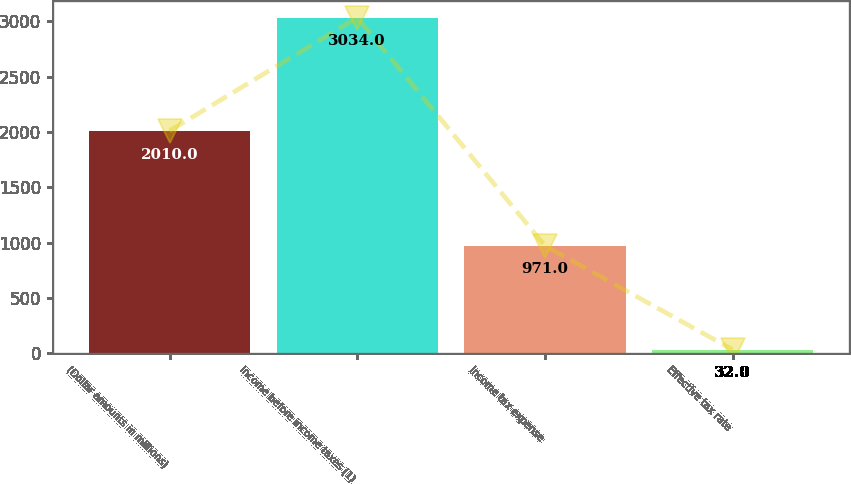<chart> <loc_0><loc_0><loc_500><loc_500><bar_chart><fcel>(Dollar amounts in millions)<fcel>Income before income taxes (1)<fcel>Income tax expense<fcel>Effective tax rate<nl><fcel>2010<fcel>3034<fcel>971<fcel>32<nl></chart> 